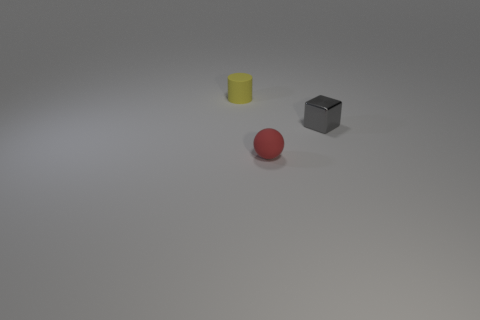How would these objects interact with each other in a physical scenario? In a physical scenario, the yellow rubber cylinder and the gray cube would remain stationary unless an outside force acted upon them. In contrast, the red sphere could roll if the surface isn't perfectly level or if given a nudge. If the sphere rolled into the cylinder or the cube, it might redirect slightly depending on the angle of contact. Which object seems the heaviest, and why? The gray cube gives the impression of being the heaviest due to its solid appearance and matte texture, which is often associated with denser materials like metal. In comparison, the yellow cylinder and the red sphere, likely being made of rubber and plastic respectively, would be lighter. 